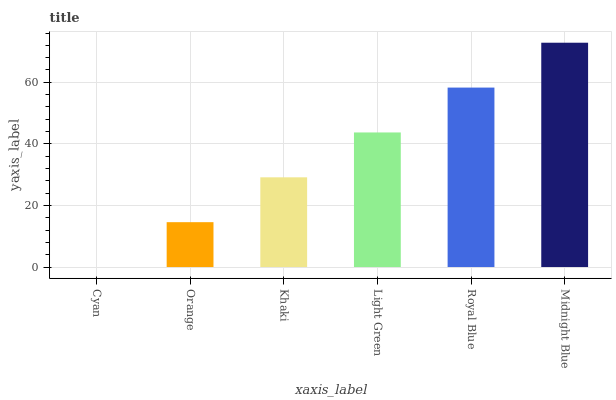Is Cyan the minimum?
Answer yes or no. Yes. Is Midnight Blue the maximum?
Answer yes or no. Yes. Is Orange the minimum?
Answer yes or no. No. Is Orange the maximum?
Answer yes or no. No. Is Orange greater than Cyan?
Answer yes or no. Yes. Is Cyan less than Orange?
Answer yes or no. Yes. Is Cyan greater than Orange?
Answer yes or no. No. Is Orange less than Cyan?
Answer yes or no. No. Is Light Green the high median?
Answer yes or no. Yes. Is Khaki the low median?
Answer yes or no. Yes. Is Midnight Blue the high median?
Answer yes or no. No. Is Midnight Blue the low median?
Answer yes or no. No. 